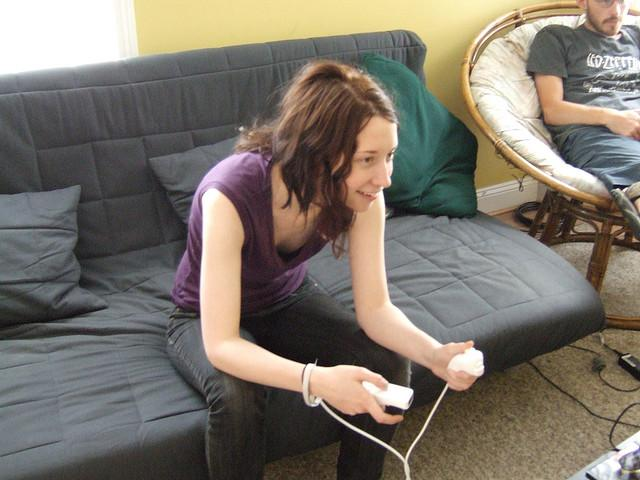What setting are these types of seating often seen in? Please explain your reasoning. apartment. These are often used by people in houses and would not be used in rich houses like b. 